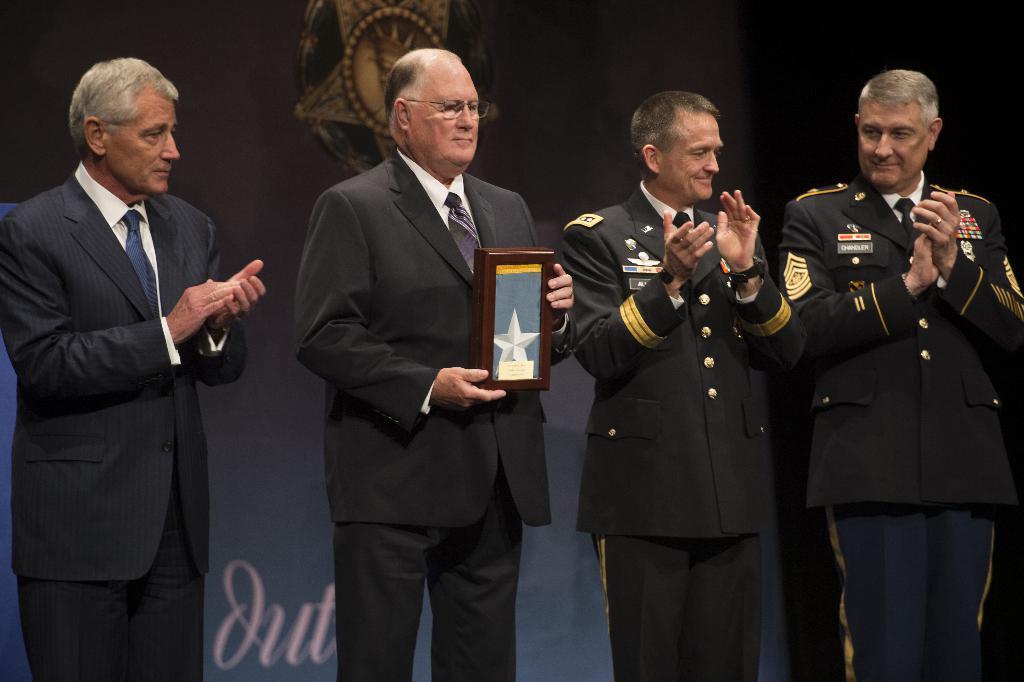In one or two sentences, can you explain what this image depicts? In this image there are two officers on the right side and two men on the left side. In the middle there is a man who is holding the memento. In the background there is a banner. Three persons are clapping their hands. 